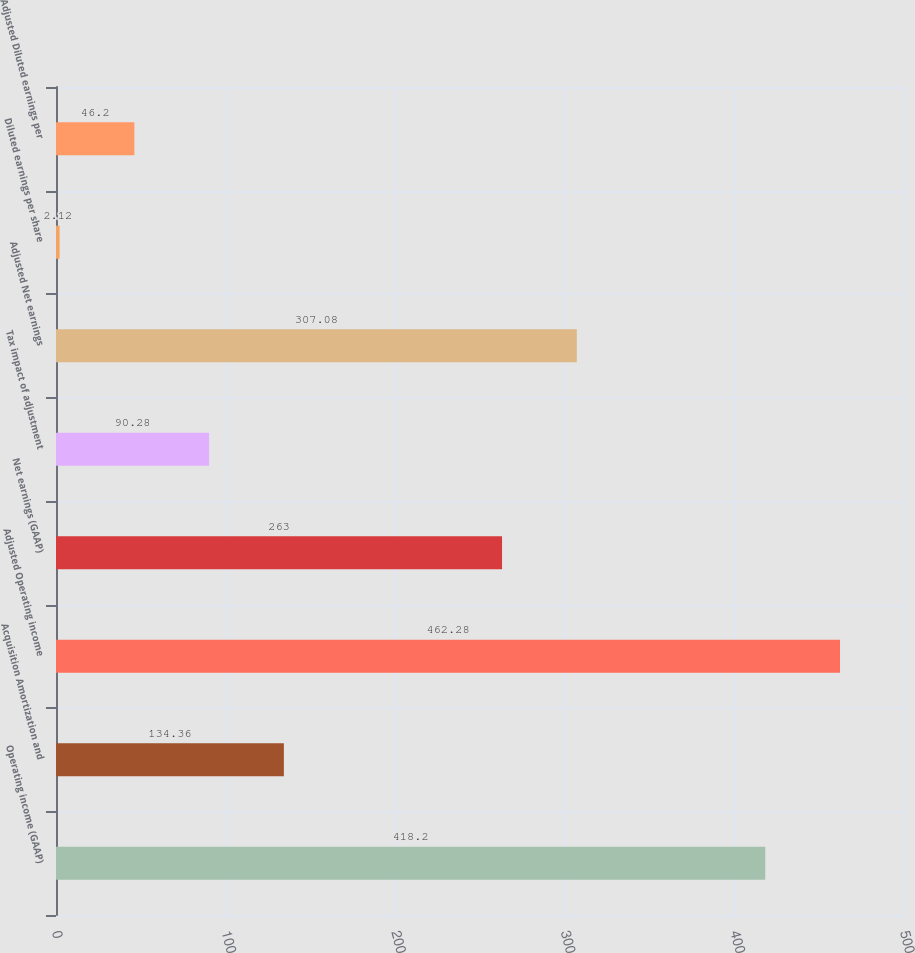<chart> <loc_0><loc_0><loc_500><loc_500><bar_chart><fcel>Operating income (GAAP)<fcel>Acquisition Amortization and<fcel>Adjusted Operating income<fcel>Net earnings (GAAP)<fcel>Tax impact of adjustment<fcel>Adjusted Net earnings<fcel>Diluted earnings per share<fcel>Adjusted Diluted earnings per<nl><fcel>418.2<fcel>134.36<fcel>462.28<fcel>263<fcel>90.28<fcel>307.08<fcel>2.12<fcel>46.2<nl></chart> 